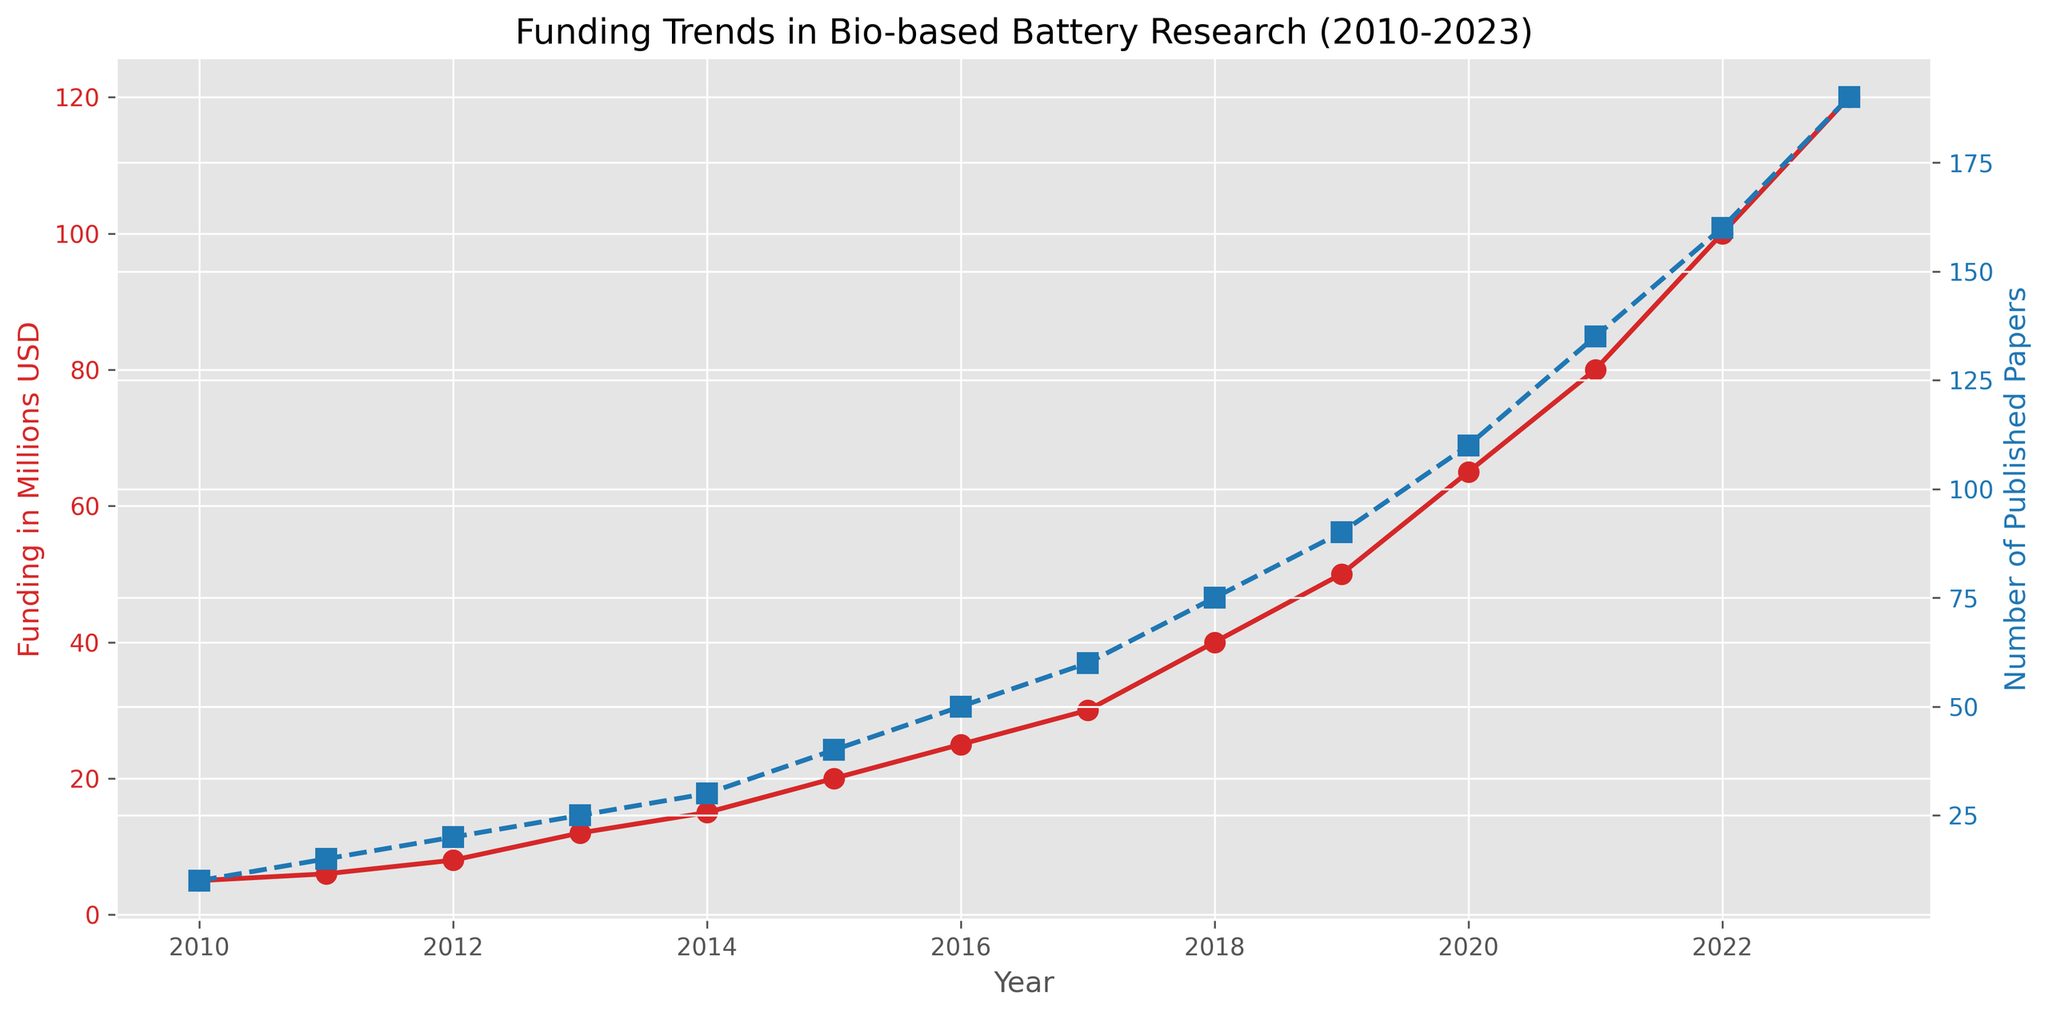What general trend do you observe in the funding for bio-based battery research from 2010 to 2023? Over the years, the funding for bio-based battery research has consistently increased. The trend is a steady rise from $5 million in 2010 to $120 million in 2023.
Answer: Increasing By how much did the funding increase from 2013 to 2020? Funding in 2013 was $12 million and in 2020, it was $65 million. The increase is $65 million - $12 million = $53 million.
Answer: $53 million What is the average number of published papers per year from 2019 to 2023? The numbers of published papers from 2019 to 2023 are 90, 110, 135, 160, and 190. The average is (90 + 110 + 135 + 160 + 190) / 5 = 685 / 5 = 137.
Answer: 137 In which year was there the largest increase in the number of published papers compared to the previous year? From 2022 to 2023, the number of published papers increased from 160 to 190, which is an increase of 30. This is the largest annual increase when compared to other years.
Answer: 2023 What is the ratio of the number of published papers in 2023 to the number in 2013? In 2023, there were 190 published papers and in 2013, there were 25 published papers. The ratio is 190 / 25 = 7.6.
Answer: 7.6 Compare the trends of funding and the number of published papers between 2010 and 2023. Both funding and the number of published papers show an increasing trend from 2010 to 2023. Funding rose from $5 million to $120 million, and the number of published papers increased from 10 to 190. Both trends indicate a positive and significant growth over time.
Answer: Both increasing Which year's data point marks the first year when funding surpasses $50 million while the number of published papers is at least 90? In 2019, funding surpassed $50 million ($50 million) and the number of published papers reached 90.
Answer: 2019 